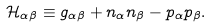<formula> <loc_0><loc_0><loc_500><loc_500>\mathcal { H } _ { \alpha \beta } \equiv g _ { \alpha \beta } + n _ { \alpha } n _ { \beta } - p _ { \alpha } p _ { \beta } .</formula> 